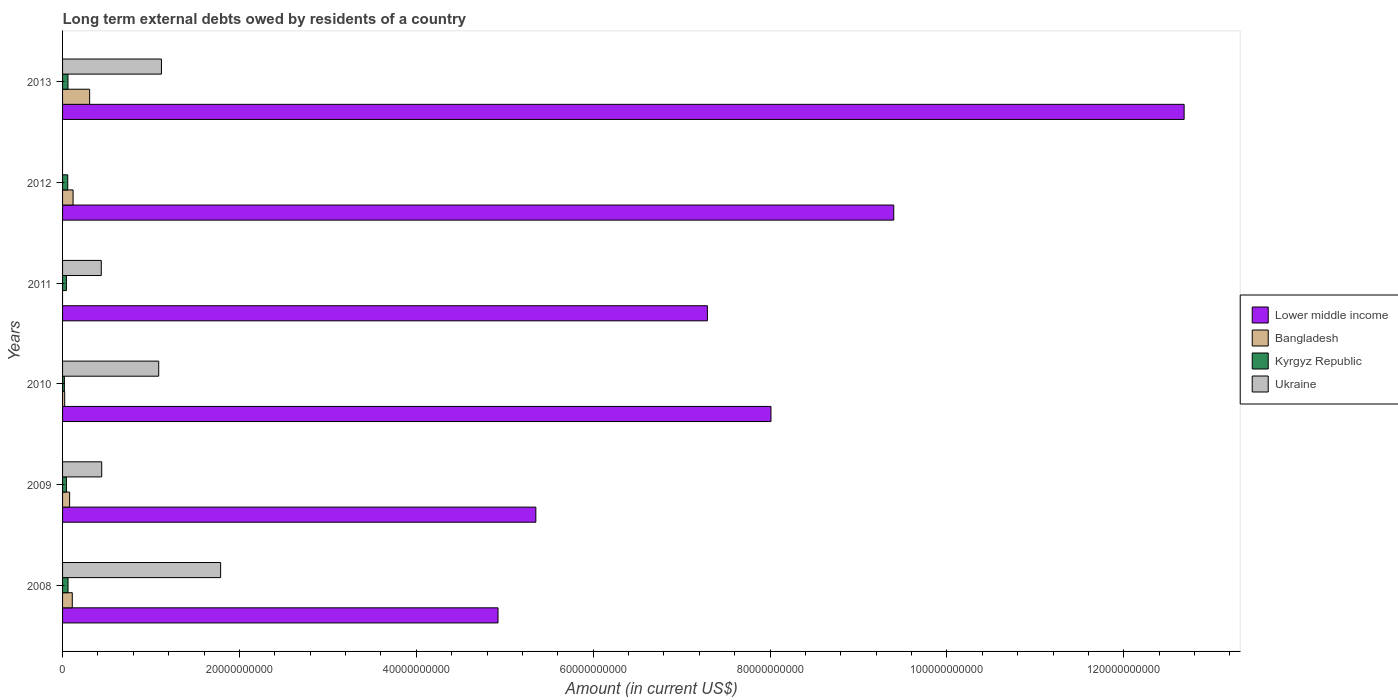How many different coloured bars are there?
Provide a succinct answer. 4. In how many cases, is the number of bars for a given year not equal to the number of legend labels?
Your answer should be compact. 2. What is the amount of long-term external debts owed by residents in Bangladesh in 2012?
Make the answer very short. 1.19e+09. Across all years, what is the maximum amount of long-term external debts owed by residents in Bangladesh?
Your response must be concise. 3.06e+09. Across all years, what is the minimum amount of long-term external debts owed by residents in Kyrgyz Republic?
Ensure brevity in your answer.  2.06e+08. In which year was the amount of long-term external debts owed by residents in Ukraine maximum?
Provide a succinct answer. 2008. What is the total amount of long-term external debts owed by residents in Lower middle income in the graph?
Your answer should be very brief. 4.77e+11. What is the difference between the amount of long-term external debts owed by residents in Kyrgyz Republic in 2008 and that in 2010?
Your answer should be compact. 4.11e+08. What is the difference between the amount of long-term external debts owed by residents in Kyrgyz Republic in 2010 and the amount of long-term external debts owed by residents in Ukraine in 2011?
Provide a succinct answer. -4.17e+09. What is the average amount of long-term external debts owed by residents in Lower middle income per year?
Make the answer very short. 7.94e+1. In the year 2009, what is the difference between the amount of long-term external debts owed by residents in Bangladesh and amount of long-term external debts owed by residents in Lower middle income?
Your answer should be very brief. -5.27e+1. What is the ratio of the amount of long-term external debts owed by residents in Lower middle income in 2008 to that in 2009?
Keep it short and to the point. 0.92. Is the amount of long-term external debts owed by residents in Kyrgyz Republic in 2009 less than that in 2011?
Provide a short and direct response. No. Is the difference between the amount of long-term external debts owed by residents in Bangladesh in 2010 and 2013 greater than the difference between the amount of long-term external debts owed by residents in Lower middle income in 2010 and 2013?
Provide a succinct answer. Yes. What is the difference between the highest and the second highest amount of long-term external debts owed by residents in Bangladesh?
Your answer should be compact. 1.87e+09. What is the difference between the highest and the lowest amount of long-term external debts owed by residents in Lower middle income?
Offer a very short reply. 7.76e+1. In how many years, is the amount of long-term external debts owed by residents in Ukraine greater than the average amount of long-term external debts owed by residents in Ukraine taken over all years?
Your response must be concise. 3. How many bars are there?
Make the answer very short. 22. Are all the bars in the graph horizontal?
Offer a very short reply. Yes. What is the difference between two consecutive major ticks on the X-axis?
Your response must be concise. 2.00e+1. Are the values on the major ticks of X-axis written in scientific E-notation?
Your response must be concise. No. Does the graph contain any zero values?
Provide a short and direct response. Yes. Where does the legend appear in the graph?
Offer a very short reply. Center right. How are the legend labels stacked?
Your answer should be compact. Vertical. What is the title of the graph?
Give a very brief answer. Long term external debts owed by residents of a country. What is the label or title of the X-axis?
Make the answer very short. Amount (in current US$). What is the label or title of the Y-axis?
Provide a short and direct response. Years. What is the Amount (in current US$) in Lower middle income in 2008?
Your answer should be very brief. 4.92e+1. What is the Amount (in current US$) of Bangladesh in 2008?
Your response must be concise. 1.10e+09. What is the Amount (in current US$) of Kyrgyz Republic in 2008?
Provide a short and direct response. 6.17e+08. What is the Amount (in current US$) in Ukraine in 2008?
Provide a short and direct response. 1.79e+1. What is the Amount (in current US$) of Lower middle income in 2009?
Your answer should be compact. 5.35e+1. What is the Amount (in current US$) of Bangladesh in 2009?
Make the answer very short. 7.97e+08. What is the Amount (in current US$) of Kyrgyz Republic in 2009?
Provide a short and direct response. 4.35e+08. What is the Amount (in current US$) of Ukraine in 2009?
Give a very brief answer. 4.43e+09. What is the Amount (in current US$) of Lower middle income in 2010?
Provide a short and direct response. 8.01e+1. What is the Amount (in current US$) in Bangladesh in 2010?
Provide a short and direct response. 2.40e+08. What is the Amount (in current US$) in Kyrgyz Republic in 2010?
Provide a succinct answer. 2.06e+08. What is the Amount (in current US$) in Ukraine in 2010?
Offer a terse response. 1.09e+1. What is the Amount (in current US$) of Lower middle income in 2011?
Offer a very short reply. 7.29e+1. What is the Amount (in current US$) of Kyrgyz Republic in 2011?
Ensure brevity in your answer.  4.32e+08. What is the Amount (in current US$) in Ukraine in 2011?
Ensure brevity in your answer.  4.38e+09. What is the Amount (in current US$) in Lower middle income in 2012?
Keep it short and to the point. 9.40e+1. What is the Amount (in current US$) in Bangladesh in 2012?
Provide a succinct answer. 1.19e+09. What is the Amount (in current US$) of Kyrgyz Republic in 2012?
Ensure brevity in your answer.  5.87e+08. What is the Amount (in current US$) of Ukraine in 2012?
Provide a succinct answer. 0. What is the Amount (in current US$) in Lower middle income in 2013?
Your response must be concise. 1.27e+11. What is the Amount (in current US$) in Bangladesh in 2013?
Your answer should be compact. 3.06e+09. What is the Amount (in current US$) in Kyrgyz Republic in 2013?
Give a very brief answer. 6.11e+08. What is the Amount (in current US$) of Ukraine in 2013?
Keep it short and to the point. 1.12e+1. Across all years, what is the maximum Amount (in current US$) of Lower middle income?
Your response must be concise. 1.27e+11. Across all years, what is the maximum Amount (in current US$) of Bangladesh?
Provide a succinct answer. 3.06e+09. Across all years, what is the maximum Amount (in current US$) in Kyrgyz Republic?
Your answer should be compact. 6.17e+08. Across all years, what is the maximum Amount (in current US$) in Ukraine?
Your answer should be very brief. 1.79e+1. Across all years, what is the minimum Amount (in current US$) of Lower middle income?
Keep it short and to the point. 4.92e+1. Across all years, what is the minimum Amount (in current US$) of Bangladesh?
Provide a short and direct response. 0. Across all years, what is the minimum Amount (in current US$) in Kyrgyz Republic?
Your answer should be compact. 2.06e+08. Across all years, what is the minimum Amount (in current US$) in Ukraine?
Provide a succinct answer. 0. What is the total Amount (in current US$) of Lower middle income in the graph?
Provide a short and direct response. 4.77e+11. What is the total Amount (in current US$) in Bangladesh in the graph?
Your answer should be very brief. 6.39e+09. What is the total Amount (in current US$) of Kyrgyz Republic in the graph?
Offer a very short reply. 2.89e+09. What is the total Amount (in current US$) of Ukraine in the graph?
Ensure brevity in your answer.  4.87e+1. What is the difference between the Amount (in current US$) of Lower middle income in 2008 and that in 2009?
Offer a terse response. -4.28e+09. What is the difference between the Amount (in current US$) in Bangladesh in 2008 and that in 2009?
Ensure brevity in your answer.  3.01e+08. What is the difference between the Amount (in current US$) of Kyrgyz Republic in 2008 and that in 2009?
Offer a very short reply. 1.82e+08. What is the difference between the Amount (in current US$) of Ukraine in 2008 and that in 2009?
Provide a succinct answer. 1.34e+1. What is the difference between the Amount (in current US$) in Lower middle income in 2008 and that in 2010?
Give a very brief answer. -3.09e+1. What is the difference between the Amount (in current US$) in Bangladesh in 2008 and that in 2010?
Keep it short and to the point. 8.58e+08. What is the difference between the Amount (in current US$) in Kyrgyz Republic in 2008 and that in 2010?
Your answer should be compact. 4.11e+08. What is the difference between the Amount (in current US$) of Ukraine in 2008 and that in 2010?
Offer a very short reply. 7.00e+09. What is the difference between the Amount (in current US$) of Lower middle income in 2008 and that in 2011?
Offer a very short reply. -2.37e+1. What is the difference between the Amount (in current US$) of Kyrgyz Republic in 2008 and that in 2011?
Offer a very short reply. 1.85e+08. What is the difference between the Amount (in current US$) of Ukraine in 2008 and that in 2011?
Make the answer very short. 1.35e+1. What is the difference between the Amount (in current US$) in Lower middle income in 2008 and that in 2012?
Provide a short and direct response. -4.47e+1. What is the difference between the Amount (in current US$) of Bangladesh in 2008 and that in 2012?
Offer a very short reply. -9.02e+07. What is the difference between the Amount (in current US$) in Kyrgyz Republic in 2008 and that in 2012?
Make the answer very short. 3.01e+07. What is the difference between the Amount (in current US$) in Lower middle income in 2008 and that in 2013?
Give a very brief answer. -7.76e+1. What is the difference between the Amount (in current US$) in Bangladesh in 2008 and that in 2013?
Your answer should be compact. -1.96e+09. What is the difference between the Amount (in current US$) in Kyrgyz Republic in 2008 and that in 2013?
Keep it short and to the point. 6.22e+06. What is the difference between the Amount (in current US$) in Ukraine in 2008 and that in 2013?
Keep it short and to the point. 6.69e+09. What is the difference between the Amount (in current US$) in Lower middle income in 2009 and that in 2010?
Offer a terse response. -2.66e+1. What is the difference between the Amount (in current US$) of Bangladesh in 2009 and that in 2010?
Provide a short and direct response. 5.57e+08. What is the difference between the Amount (in current US$) of Kyrgyz Republic in 2009 and that in 2010?
Your response must be concise. 2.29e+08. What is the difference between the Amount (in current US$) in Ukraine in 2009 and that in 2010?
Give a very brief answer. -6.44e+09. What is the difference between the Amount (in current US$) of Lower middle income in 2009 and that in 2011?
Offer a terse response. -1.94e+1. What is the difference between the Amount (in current US$) of Kyrgyz Republic in 2009 and that in 2011?
Offer a very short reply. 3.60e+06. What is the difference between the Amount (in current US$) of Ukraine in 2009 and that in 2011?
Keep it short and to the point. 5.08e+07. What is the difference between the Amount (in current US$) in Lower middle income in 2009 and that in 2012?
Your answer should be compact. -4.05e+1. What is the difference between the Amount (in current US$) of Bangladesh in 2009 and that in 2012?
Give a very brief answer. -3.91e+08. What is the difference between the Amount (in current US$) of Kyrgyz Republic in 2009 and that in 2012?
Make the answer very short. -1.52e+08. What is the difference between the Amount (in current US$) of Lower middle income in 2009 and that in 2013?
Offer a terse response. -7.33e+1. What is the difference between the Amount (in current US$) of Bangladesh in 2009 and that in 2013?
Make the answer very short. -2.26e+09. What is the difference between the Amount (in current US$) of Kyrgyz Republic in 2009 and that in 2013?
Provide a short and direct response. -1.76e+08. What is the difference between the Amount (in current US$) in Ukraine in 2009 and that in 2013?
Keep it short and to the point. -6.75e+09. What is the difference between the Amount (in current US$) in Lower middle income in 2010 and that in 2011?
Provide a succinct answer. 7.19e+09. What is the difference between the Amount (in current US$) of Kyrgyz Republic in 2010 and that in 2011?
Offer a very short reply. -2.26e+08. What is the difference between the Amount (in current US$) of Ukraine in 2010 and that in 2011?
Offer a terse response. 6.50e+09. What is the difference between the Amount (in current US$) of Lower middle income in 2010 and that in 2012?
Ensure brevity in your answer.  -1.39e+1. What is the difference between the Amount (in current US$) in Bangladesh in 2010 and that in 2012?
Provide a short and direct response. -9.48e+08. What is the difference between the Amount (in current US$) of Kyrgyz Republic in 2010 and that in 2012?
Offer a terse response. -3.81e+08. What is the difference between the Amount (in current US$) of Lower middle income in 2010 and that in 2013?
Provide a short and direct response. -4.67e+1. What is the difference between the Amount (in current US$) in Bangladesh in 2010 and that in 2013?
Make the answer very short. -2.82e+09. What is the difference between the Amount (in current US$) of Kyrgyz Republic in 2010 and that in 2013?
Ensure brevity in your answer.  -4.05e+08. What is the difference between the Amount (in current US$) of Ukraine in 2010 and that in 2013?
Your response must be concise. -3.09e+08. What is the difference between the Amount (in current US$) of Lower middle income in 2011 and that in 2012?
Make the answer very short. -2.11e+1. What is the difference between the Amount (in current US$) of Kyrgyz Republic in 2011 and that in 2012?
Keep it short and to the point. -1.55e+08. What is the difference between the Amount (in current US$) of Lower middle income in 2011 and that in 2013?
Ensure brevity in your answer.  -5.39e+1. What is the difference between the Amount (in current US$) of Kyrgyz Republic in 2011 and that in 2013?
Keep it short and to the point. -1.79e+08. What is the difference between the Amount (in current US$) of Ukraine in 2011 and that in 2013?
Your answer should be very brief. -6.80e+09. What is the difference between the Amount (in current US$) of Lower middle income in 2012 and that in 2013?
Offer a terse response. -3.28e+1. What is the difference between the Amount (in current US$) in Bangladesh in 2012 and that in 2013?
Provide a succinct answer. -1.87e+09. What is the difference between the Amount (in current US$) of Kyrgyz Republic in 2012 and that in 2013?
Your answer should be very brief. -2.39e+07. What is the difference between the Amount (in current US$) of Lower middle income in 2008 and the Amount (in current US$) of Bangladesh in 2009?
Make the answer very short. 4.84e+1. What is the difference between the Amount (in current US$) in Lower middle income in 2008 and the Amount (in current US$) in Kyrgyz Republic in 2009?
Offer a terse response. 4.88e+1. What is the difference between the Amount (in current US$) in Lower middle income in 2008 and the Amount (in current US$) in Ukraine in 2009?
Your answer should be very brief. 4.48e+1. What is the difference between the Amount (in current US$) in Bangladesh in 2008 and the Amount (in current US$) in Kyrgyz Republic in 2009?
Keep it short and to the point. 6.63e+08. What is the difference between the Amount (in current US$) of Bangladesh in 2008 and the Amount (in current US$) of Ukraine in 2009?
Your response must be concise. -3.33e+09. What is the difference between the Amount (in current US$) in Kyrgyz Republic in 2008 and the Amount (in current US$) in Ukraine in 2009?
Offer a terse response. -3.81e+09. What is the difference between the Amount (in current US$) in Lower middle income in 2008 and the Amount (in current US$) in Bangladesh in 2010?
Keep it short and to the point. 4.90e+1. What is the difference between the Amount (in current US$) in Lower middle income in 2008 and the Amount (in current US$) in Kyrgyz Republic in 2010?
Keep it short and to the point. 4.90e+1. What is the difference between the Amount (in current US$) in Lower middle income in 2008 and the Amount (in current US$) in Ukraine in 2010?
Give a very brief answer. 3.84e+1. What is the difference between the Amount (in current US$) of Bangladesh in 2008 and the Amount (in current US$) of Kyrgyz Republic in 2010?
Make the answer very short. 8.92e+08. What is the difference between the Amount (in current US$) of Bangladesh in 2008 and the Amount (in current US$) of Ukraine in 2010?
Provide a succinct answer. -9.77e+09. What is the difference between the Amount (in current US$) of Kyrgyz Republic in 2008 and the Amount (in current US$) of Ukraine in 2010?
Make the answer very short. -1.03e+1. What is the difference between the Amount (in current US$) in Lower middle income in 2008 and the Amount (in current US$) in Kyrgyz Republic in 2011?
Offer a very short reply. 4.88e+1. What is the difference between the Amount (in current US$) of Lower middle income in 2008 and the Amount (in current US$) of Ukraine in 2011?
Give a very brief answer. 4.49e+1. What is the difference between the Amount (in current US$) in Bangladesh in 2008 and the Amount (in current US$) in Kyrgyz Republic in 2011?
Make the answer very short. 6.67e+08. What is the difference between the Amount (in current US$) of Bangladesh in 2008 and the Amount (in current US$) of Ukraine in 2011?
Your answer should be compact. -3.28e+09. What is the difference between the Amount (in current US$) in Kyrgyz Republic in 2008 and the Amount (in current US$) in Ukraine in 2011?
Give a very brief answer. -3.76e+09. What is the difference between the Amount (in current US$) of Lower middle income in 2008 and the Amount (in current US$) of Bangladesh in 2012?
Keep it short and to the point. 4.80e+1. What is the difference between the Amount (in current US$) of Lower middle income in 2008 and the Amount (in current US$) of Kyrgyz Republic in 2012?
Your answer should be compact. 4.86e+1. What is the difference between the Amount (in current US$) of Bangladesh in 2008 and the Amount (in current US$) of Kyrgyz Republic in 2012?
Offer a very short reply. 5.11e+08. What is the difference between the Amount (in current US$) in Lower middle income in 2008 and the Amount (in current US$) in Bangladesh in 2013?
Keep it short and to the point. 4.62e+1. What is the difference between the Amount (in current US$) in Lower middle income in 2008 and the Amount (in current US$) in Kyrgyz Republic in 2013?
Your answer should be compact. 4.86e+1. What is the difference between the Amount (in current US$) of Lower middle income in 2008 and the Amount (in current US$) of Ukraine in 2013?
Make the answer very short. 3.81e+1. What is the difference between the Amount (in current US$) in Bangladesh in 2008 and the Amount (in current US$) in Kyrgyz Republic in 2013?
Your answer should be very brief. 4.88e+08. What is the difference between the Amount (in current US$) in Bangladesh in 2008 and the Amount (in current US$) in Ukraine in 2013?
Ensure brevity in your answer.  -1.01e+1. What is the difference between the Amount (in current US$) of Kyrgyz Republic in 2008 and the Amount (in current US$) of Ukraine in 2013?
Ensure brevity in your answer.  -1.06e+1. What is the difference between the Amount (in current US$) of Lower middle income in 2009 and the Amount (in current US$) of Bangladesh in 2010?
Give a very brief answer. 5.33e+1. What is the difference between the Amount (in current US$) of Lower middle income in 2009 and the Amount (in current US$) of Kyrgyz Republic in 2010?
Provide a succinct answer. 5.33e+1. What is the difference between the Amount (in current US$) in Lower middle income in 2009 and the Amount (in current US$) in Ukraine in 2010?
Provide a succinct answer. 4.26e+1. What is the difference between the Amount (in current US$) of Bangladesh in 2009 and the Amount (in current US$) of Kyrgyz Republic in 2010?
Give a very brief answer. 5.91e+08. What is the difference between the Amount (in current US$) of Bangladesh in 2009 and the Amount (in current US$) of Ukraine in 2010?
Provide a succinct answer. -1.01e+1. What is the difference between the Amount (in current US$) of Kyrgyz Republic in 2009 and the Amount (in current US$) of Ukraine in 2010?
Provide a short and direct response. -1.04e+1. What is the difference between the Amount (in current US$) in Lower middle income in 2009 and the Amount (in current US$) in Kyrgyz Republic in 2011?
Your response must be concise. 5.31e+1. What is the difference between the Amount (in current US$) of Lower middle income in 2009 and the Amount (in current US$) of Ukraine in 2011?
Make the answer very short. 4.91e+1. What is the difference between the Amount (in current US$) of Bangladesh in 2009 and the Amount (in current US$) of Kyrgyz Republic in 2011?
Give a very brief answer. 3.66e+08. What is the difference between the Amount (in current US$) of Bangladesh in 2009 and the Amount (in current US$) of Ukraine in 2011?
Provide a short and direct response. -3.58e+09. What is the difference between the Amount (in current US$) of Kyrgyz Republic in 2009 and the Amount (in current US$) of Ukraine in 2011?
Offer a very short reply. -3.94e+09. What is the difference between the Amount (in current US$) in Lower middle income in 2009 and the Amount (in current US$) in Bangladesh in 2012?
Offer a very short reply. 5.23e+1. What is the difference between the Amount (in current US$) of Lower middle income in 2009 and the Amount (in current US$) of Kyrgyz Republic in 2012?
Make the answer very short. 5.29e+1. What is the difference between the Amount (in current US$) in Bangladesh in 2009 and the Amount (in current US$) in Kyrgyz Republic in 2012?
Your answer should be very brief. 2.10e+08. What is the difference between the Amount (in current US$) in Lower middle income in 2009 and the Amount (in current US$) in Bangladesh in 2013?
Your answer should be compact. 5.05e+1. What is the difference between the Amount (in current US$) in Lower middle income in 2009 and the Amount (in current US$) in Kyrgyz Republic in 2013?
Provide a succinct answer. 5.29e+1. What is the difference between the Amount (in current US$) of Lower middle income in 2009 and the Amount (in current US$) of Ukraine in 2013?
Offer a very short reply. 4.23e+1. What is the difference between the Amount (in current US$) in Bangladesh in 2009 and the Amount (in current US$) in Kyrgyz Republic in 2013?
Provide a succinct answer. 1.86e+08. What is the difference between the Amount (in current US$) of Bangladesh in 2009 and the Amount (in current US$) of Ukraine in 2013?
Your response must be concise. -1.04e+1. What is the difference between the Amount (in current US$) of Kyrgyz Republic in 2009 and the Amount (in current US$) of Ukraine in 2013?
Give a very brief answer. -1.07e+1. What is the difference between the Amount (in current US$) in Lower middle income in 2010 and the Amount (in current US$) in Kyrgyz Republic in 2011?
Give a very brief answer. 7.97e+1. What is the difference between the Amount (in current US$) in Lower middle income in 2010 and the Amount (in current US$) in Ukraine in 2011?
Give a very brief answer. 7.57e+1. What is the difference between the Amount (in current US$) of Bangladesh in 2010 and the Amount (in current US$) of Kyrgyz Republic in 2011?
Offer a very short reply. -1.91e+08. What is the difference between the Amount (in current US$) of Bangladesh in 2010 and the Amount (in current US$) of Ukraine in 2011?
Keep it short and to the point. -4.14e+09. What is the difference between the Amount (in current US$) in Kyrgyz Republic in 2010 and the Amount (in current US$) in Ukraine in 2011?
Offer a very short reply. -4.17e+09. What is the difference between the Amount (in current US$) of Lower middle income in 2010 and the Amount (in current US$) of Bangladesh in 2012?
Provide a succinct answer. 7.89e+1. What is the difference between the Amount (in current US$) in Lower middle income in 2010 and the Amount (in current US$) in Kyrgyz Republic in 2012?
Provide a succinct answer. 7.95e+1. What is the difference between the Amount (in current US$) in Bangladesh in 2010 and the Amount (in current US$) in Kyrgyz Republic in 2012?
Offer a very short reply. -3.47e+08. What is the difference between the Amount (in current US$) in Lower middle income in 2010 and the Amount (in current US$) in Bangladesh in 2013?
Make the answer very short. 7.70e+1. What is the difference between the Amount (in current US$) of Lower middle income in 2010 and the Amount (in current US$) of Kyrgyz Republic in 2013?
Give a very brief answer. 7.95e+1. What is the difference between the Amount (in current US$) of Lower middle income in 2010 and the Amount (in current US$) of Ukraine in 2013?
Give a very brief answer. 6.89e+1. What is the difference between the Amount (in current US$) of Bangladesh in 2010 and the Amount (in current US$) of Kyrgyz Republic in 2013?
Offer a very short reply. -3.71e+08. What is the difference between the Amount (in current US$) of Bangladesh in 2010 and the Amount (in current US$) of Ukraine in 2013?
Ensure brevity in your answer.  -1.09e+1. What is the difference between the Amount (in current US$) in Kyrgyz Republic in 2010 and the Amount (in current US$) in Ukraine in 2013?
Offer a terse response. -1.10e+1. What is the difference between the Amount (in current US$) in Lower middle income in 2011 and the Amount (in current US$) in Bangladesh in 2012?
Your response must be concise. 7.17e+1. What is the difference between the Amount (in current US$) in Lower middle income in 2011 and the Amount (in current US$) in Kyrgyz Republic in 2012?
Your response must be concise. 7.23e+1. What is the difference between the Amount (in current US$) of Lower middle income in 2011 and the Amount (in current US$) of Bangladesh in 2013?
Provide a succinct answer. 6.98e+1. What is the difference between the Amount (in current US$) in Lower middle income in 2011 and the Amount (in current US$) in Kyrgyz Republic in 2013?
Ensure brevity in your answer.  7.23e+1. What is the difference between the Amount (in current US$) in Lower middle income in 2011 and the Amount (in current US$) in Ukraine in 2013?
Make the answer very short. 6.17e+1. What is the difference between the Amount (in current US$) of Kyrgyz Republic in 2011 and the Amount (in current US$) of Ukraine in 2013?
Your response must be concise. -1.07e+1. What is the difference between the Amount (in current US$) in Lower middle income in 2012 and the Amount (in current US$) in Bangladesh in 2013?
Give a very brief answer. 9.09e+1. What is the difference between the Amount (in current US$) of Lower middle income in 2012 and the Amount (in current US$) of Kyrgyz Republic in 2013?
Provide a short and direct response. 9.34e+1. What is the difference between the Amount (in current US$) in Lower middle income in 2012 and the Amount (in current US$) in Ukraine in 2013?
Provide a succinct answer. 8.28e+1. What is the difference between the Amount (in current US$) in Bangladesh in 2012 and the Amount (in current US$) in Kyrgyz Republic in 2013?
Keep it short and to the point. 5.78e+08. What is the difference between the Amount (in current US$) of Bangladesh in 2012 and the Amount (in current US$) of Ukraine in 2013?
Provide a short and direct response. -9.99e+09. What is the difference between the Amount (in current US$) in Kyrgyz Republic in 2012 and the Amount (in current US$) in Ukraine in 2013?
Offer a very short reply. -1.06e+1. What is the average Amount (in current US$) in Lower middle income per year?
Provide a succinct answer. 7.94e+1. What is the average Amount (in current US$) of Bangladesh per year?
Ensure brevity in your answer.  1.06e+09. What is the average Amount (in current US$) of Kyrgyz Republic per year?
Keep it short and to the point. 4.81e+08. What is the average Amount (in current US$) in Ukraine per year?
Keep it short and to the point. 8.12e+09. In the year 2008, what is the difference between the Amount (in current US$) in Lower middle income and Amount (in current US$) in Bangladesh?
Your response must be concise. 4.81e+1. In the year 2008, what is the difference between the Amount (in current US$) in Lower middle income and Amount (in current US$) in Kyrgyz Republic?
Your answer should be compact. 4.86e+1. In the year 2008, what is the difference between the Amount (in current US$) in Lower middle income and Amount (in current US$) in Ukraine?
Your answer should be compact. 3.14e+1. In the year 2008, what is the difference between the Amount (in current US$) in Bangladesh and Amount (in current US$) in Kyrgyz Republic?
Provide a short and direct response. 4.81e+08. In the year 2008, what is the difference between the Amount (in current US$) of Bangladesh and Amount (in current US$) of Ukraine?
Your response must be concise. -1.68e+1. In the year 2008, what is the difference between the Amount (in current US$) in Kyrgyz Republic and Amount (in current US$) in Ukraine?
Provide a short and direct response. -1.73e+1. In the year 2009, what is the difference between the Amount (in current US$) of Lower middle income and Amount (in current US$) of Bangladesh?
Your response must be concise. 5.27e+1. In the year 2009, what is the difference between the Amount (in current US$) in Lower middle income and Amount (in current US$) in Kyrgyz Republic?
Make the answer very short. 5.31e+1. In the year 2009, what is the difference between the Amount (in current US$) of Lower middle income and Amount (in current US$) of Ukraine?
Ensure brevity in your answer.  4.91e+1. In the year 2009, what is the difference between the Amount (in current US$) in Bangladesh and Amount (in current US$) in Kyrgyz Republic?
Offer a terse response. 3.62e+08. In the year 2009, what is the difference between the Amount (in current US$) in Bangladesh and Amount (in current US$) in Ukraine?
Give a very brief answer. -3.63e+09. In the year 2009, what is the difference between the Amount (in current US$) of Kyrgyz Republic and Amount (in current US$) of Ukraine?
Provide a short and direct response. -3.99e+09. In the year 2010, what is the difference between the Amount (in current US$) in Lower middle income and Amount (in current US$) in Bangladesh?
Offer a terse response. 7.99e+1. In the year 2010, what is the difference between the Amount (in current US$) in Lower middle income and Amount (in current US$) in Kyrgyz Republic?
Offer a very short reply. 7.99e+1. In the year 2010, what is the difference between the Amount (in current US$) of Lower middle income and Amount (in current US$) of Ukraine?
Ensure brevity in your answer.  6.92e+1. In the year 2010, what is the difference between the Amount (in current US$) of Bangladesh and Amount (in current US$) of Kyrgyz Republic?
Your response must be concise. 3.42e+07. In the year 2010, what is the difference between the Amount (in current US$) in Bangladesh and Amount (in current US$) in Ukraine?
Your answer should be compact. -1.06e+1. In the year 2010, what is the difference between the Amount (in current US$) of Kyrgyz Republic and Amount (in current US$) of Ukraine?
Offer a very short reply. -1.07e+1. In the year 2011, what is the difference between the Amount (in current US$) in Lower middle income and Amount (in current US$) in Kyrgyz Republic?
Offer a very short reply. 7.25e+1. In the year 2011, what is the difference between the Amount (in current US$) of Lower middle income and Amount (in current US$) of Ukraine?
Make the answer very short. 6.85e+1. In the year 2011, what is the difference between the Amount (in current US$) of Kyrgyz Republic and Amount (in current US$) of Ukraine?
Offer a terse response. -3.95e+09. In the year 2012, what is the difference between the Amount (in current US$) in Lower middle income and Amount (in current US$) in Bangladesh?
Offer a terse response. 9.28e+1. In the year 2012, what is the difference between the Amount (in current US$) of Lower middle income and Amount (in current US$) of Kyrgyz Republic?
Your response must be concise. 9.34e+1. In the year 2012, what is the difference between the Amount (in current US$) of Bangladesh and Amount (in current US$) of Kyrgyz Republic?
Keep it short and to the point. 6.02e+08. In the year 2013, what is the difference between the Amount (in current US$) in Lower middle income and Amount (in current US$) in Bangladesh?
Your response must be concise. 1.24e+11. In the year 2013, what is the difference between the Amount (in current US$) of Lower middle income and Amount (in current US$) of Kyrgyz Republic?
Make the answer very short. 1.26e+11. In the year 2013, what is the difference between the Amount (in current US$) in Lower middle income and Amount (in current US$) in Ukraine?
Offer a very short reply. 1.16e+11. In the year 2013, what is the difference between the Amount (in current US$) of Bangladesh and Amount (in current US$) of Kyrgyz Republic?
Offer a very short reply. 2.45e+09. In the year 2013, what is the difference between the Amount (in current US$) of Bangladesh and Amount (in current US$) of Ukraine?
Keep it short and to the point. -8.12e+09. In the year 2013, what is the difference between the Amount (in current US$) of Kyrgyz Republic and Amount (in current US$) of Ukraine?
Make the answer very short. -1.06e+1. What is the ratio of the Amount (in current US$) in Lower middle income in 2008 to that in 2009?
Ensure brevity in your answer.  0.92. What is the ratio of the Amount (in current US$) of Bangladesh in 2008 to that in 2009?
Offer a very short reply. 1.38. What is the ratio of the Amount (in current US$) in Kyrgyz Republic in 2008 to that in 2009?
Your answer should be very brief. 1.42. What is the ratio of the Amount (in current US$) of Ukraine in 2008 to that in 2009?
Provide a succinct answer. 4.04. What is the ratio of the Amount (in current US$) of Lower middle income in 2008 to that in 2010?
Provide a short and direct response. 0.61. What is the ratio of the Amount (in current US$) in Bangladesh in 2008 to that in 2010?
Offer a very short reply. 4.57. What is the ratio of the Amount (in current US$) of Kyrgyz Republic in 2008 to that in 2010?
Provide a short and direct response. 2.99. What is the ratio of the Amount (in current US$) of Ukraine in 2008 to that in 2010?
Your response must be concise. 1.64. What is the ratio of the Amount (in current US$) in Lower middle income in 2008 to that in 2011?
Your answer should be compact. 0.68. What is the ratio of the Amount (in current US$) in Kyrgyz Republic in 2008 to that in 2011?
Provide a short and direct response. 1.43. What is the ratio of the Amount (in current US$) in Ukraine in 2008 to that in 2011?
Your response must be concise. 4.08. What is the ratio of the Amount (in current US$) in Lower middle income in 2008 to that in 2012?
Offer a very short reply. 0.52. What is the ratio of the Amount (in current US$) of Bangladesh in 2008 to that in 2012?
Give a very brief answer. 0.92. What is the ratio of the Amount (in current US$) in Kyrgyz Republic in 2008 to that in 2012?
Offer a terse response. 1.05. What is the ratio of the Amount (in current US$) of Lower middle income in 2008 to that in 2013?
Keep it short and to the point. 0.39. What is the ratio of the Amount (in current US$) in Bangladesh in 2008 to that in 2013?
Your answer should be compact. 0.36. What is the ratio of the Amount (in current US$) in Kyrgyz Republic in 2008 to that in 2013?
Keep it short and to the point. 1.01. What is the ratio of the Amount (in current US$) in Ukraine in 2008 to that in 2013?
Ensure brevity in your answer.  1.6. What is the ratio of the Amount (in current US$) in Lower middle income in 2009 to that in 2010?
Make the answer very short. 0.67. What is the ratio of the Amount (in current US$) in Bangladesh in 2009 to that in 2010?
Your answer should be compact. 3.32. What is the ratio of the Amount (in current US$) of Kyrgyz Republic in 2009 to that in 2010?
Your response must be concise. 2.11. What is the ratio of the Amount (in current US$) in Ukraine in 2009 to that in 2010?
Provide a succinct answer. 0.41. What is the ratio of the Amount (in current US$) of Lower middle income in 2009 to that in 2011?
Your answer should be compact. 0.73. What is the ratio of the Amount (in current US$) in Kyrgyz Republic in 2009 to that in 2011?
Give a very brief answer. 1.01. What is the ratio of the Amount (in current US$) in Ukraine in 2009 to that in 2011?
Make the answer very short. 1.01. What is the ratio of the Amount (in current US$) in Lower middle income in 2009 to that in 2012?
Provide a succinct answer. 0.57. What is the ratio of the Amount (in current US$) of Bangladesh in 2009 to that in 2012?
Provide a succinct answer. 0.67. What is the ratio of the Amount (in current US$) in Kyrgyz Republic in 2009 to that in 2012?
Provide a short and direct response. 0.74. What is the ratio of the Amount (in current US$) in Lower middle income in 2009 to that in 2013?
Provide a succinct answer. 0.42. What is the ratio of the Amount (in current US$) in Bangladesh in 2009 to that in 2013?
Ensure brevity in your answer.  0.26. What is the ratio of the Amount (in current US$) of Kyrgyz Republic in 2009 to that in 2013?
Your response must be concise. 0.71. What is the ratio of the Amount (in current US$) of Ukraine in 2009 to that in 2013?
Keep it short and to the point. 0.4. What is the ratio of the Amount (in current US$) in Lower middle income in 2010 to that in 2011?
Offer a terse response. 1.1. What is the ratio of the Amount (in current US$) of Kyrgyz Republic in 2010 to that in 2011?
Your response must be concise. 0.48. What is the ratio of the Amount (in current US$) in Ukraine in 2010 to that in 2011?
Provide a succinct answer. 2.48. What is the ratio of the Amount (in current US$) of Lower middle income in 2010 to that in 2012?
Your answer should be very brief. 0.85. What is the ratio of the Amount (in current US$) in Bangladesh in 2010 to that in 2012?
Give a very brief answer. 0.2. What is the ratio of the Amount (in current US$) in Kyrgyz Republic in 2010 to that in 2012?
Ensure brevity in your answer.  0.35. What is the ratio of the Amount (in current US$) in Lower middle income in 2010 to that in 2013?
Make the answer very short. 0.63. What is the ratio of the Amount (in current US$) of Bangladesh in 2010 to that in 2013?
Provide a succinct answer. 0.08. What is the ratio of the Amount (in current US$) in Kyrgyz Republic in 2010 to that in 2013?
Offer a very short reply. 0.34. What is the ratio of the Amount (in current US$) in Ukraine in 2010 to that in 2013?
Give a very brief answer. 0.97. What is the ratio of the Amount (in current US$) in Lower middle income in 2011 to that in 2012?
Keep it short and to the point. 0.78. What is the ratio of the Amount (in current US$) of Kyrgyz Republic in 2011 to that in 2012?
Ensure brevity in your answer.  0.74. What is the ratio of the Amount (in current US$) in Lower middle income in 2011 to that in 2013?
Keep it short and to the point. 0.57. What is the ratio of the Amount (in current US$) in Kyrgyz Republic in 2011 to that in 2013?
Offer a terse response. 0.71. What is the ratio of the Amount (in current US$) of Ukraine in 2011 to that in 2013?
Offer a very short reply. 0.39. What is the ratio of the Amount (in current US$) in Lower middle income in 2012 to that in 2013?
Provide a succinct answer. 0.74. What is the ratio of the Amount (in current US$) of Bangladesh in 2012 to that in 2013?
Your answer should be compact. 0.39. What is the ratio of the Amount (in current US$) in Kyrgyz Republic in 2012 to that in 2013?
Make the answer very short. 0.96. What is the difference between the highest and the second highest Amount (in current US$) in Lower middle income?
Your response must be concise. 3.28e+1. What is the difference between the highest and the second highest Amount (in current US$) in Bangladesh?
Your response must be concise. 1.87e+09. What is the difference between the highest and the second highest Amount (in current US$) in Kyrgyz Republic?
Ensure brevity in your answer.  6.22e+06. What is the difference between the highest and the second highest Amount (in current US$) in Ukraine?
Keep it short and to the point. 6.69e+09. What is the difference between the highest and the lowest Amount (in current US$) in Lower middle income?
Provide a short and direct response. 7.76e+1. What is the difference between the highest and the lowest Amount (in current US$) of Bangladesh?
Provide a short and direct response. 3.06e+09. What is the difference between the highest and the lowest Amount (in current US$) of Kyrgyz Republic?
Your answer should be compact. 4.11e+08. What is the difference between the highest and the lowest Amount (in current US$) in Ukraine?
Your response must be concise. 1.79e+1. 